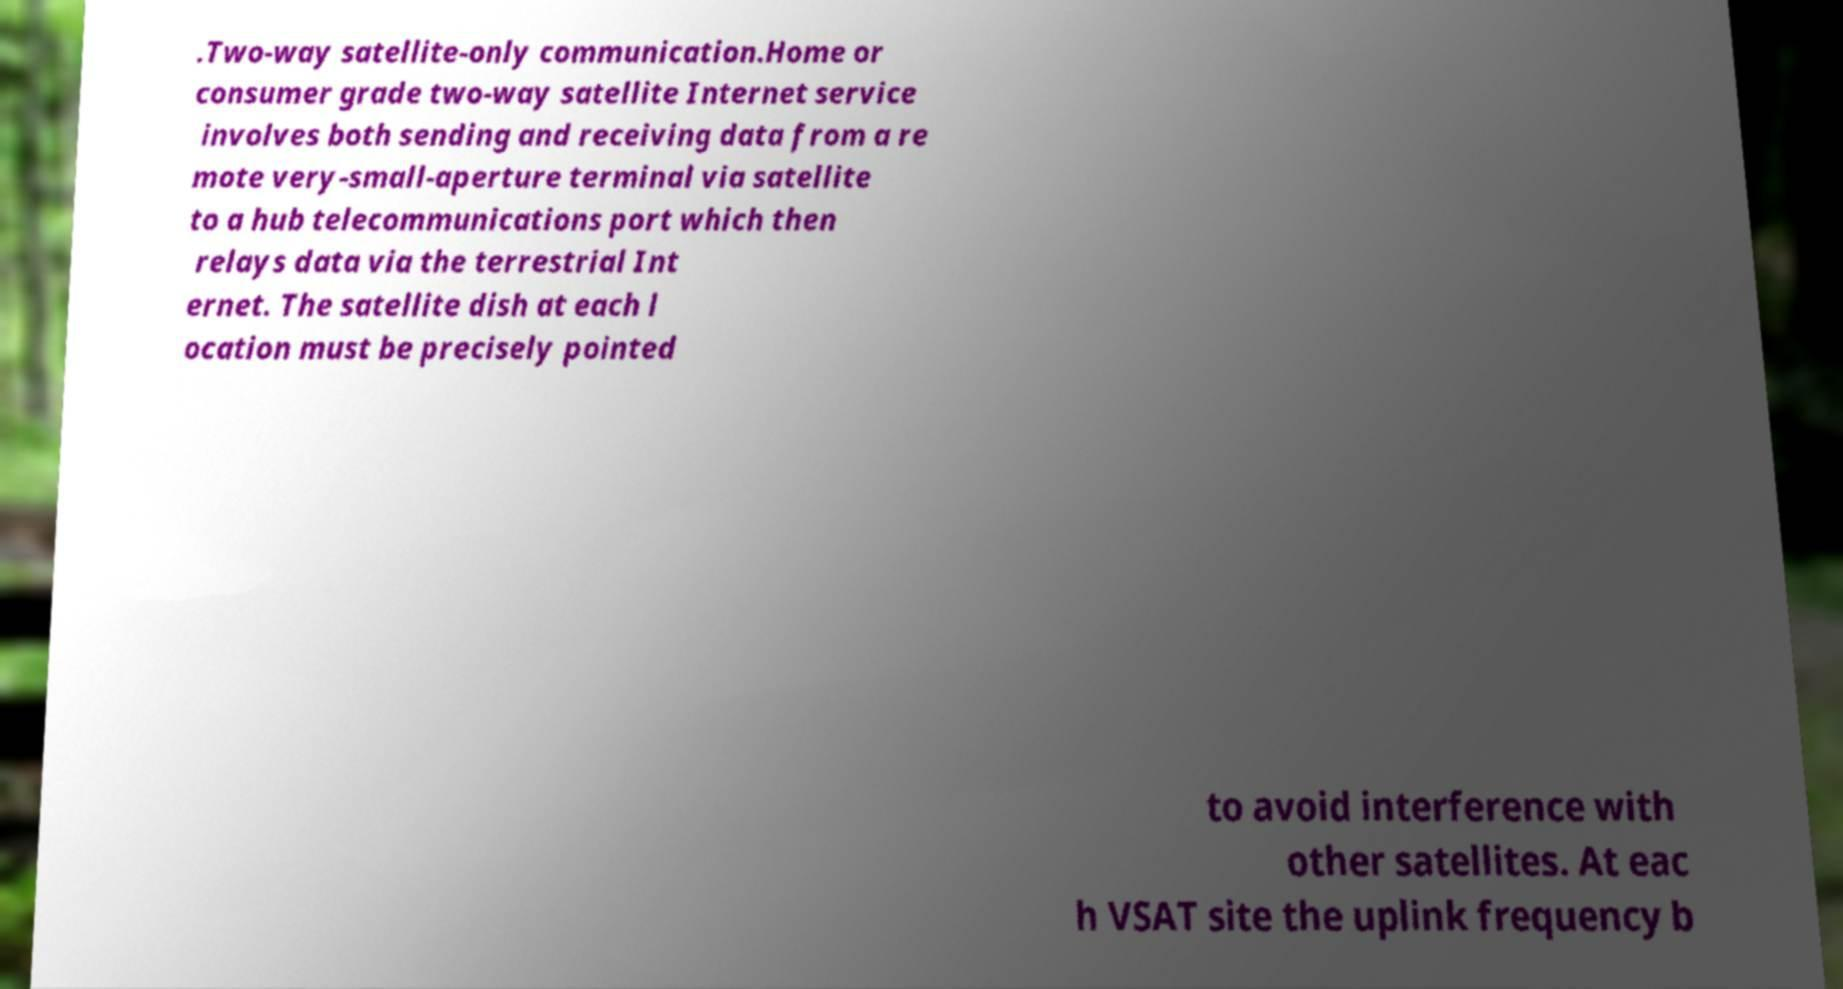I need the written content from this picture converted into text. Can you do that? .Two-way satellite-only communication.Home or consumer grade two-way satellite Internet service involves both sending and receiving data from a re mote very-small-aperture terminal via satellite to a hub telecommunications port which then relays data via the terrestrial Int ernet. The satellite dish at each l ocation must be precisely pointed to avoid interference with other satellites. At eac h VSAT site the uplink frequency b 